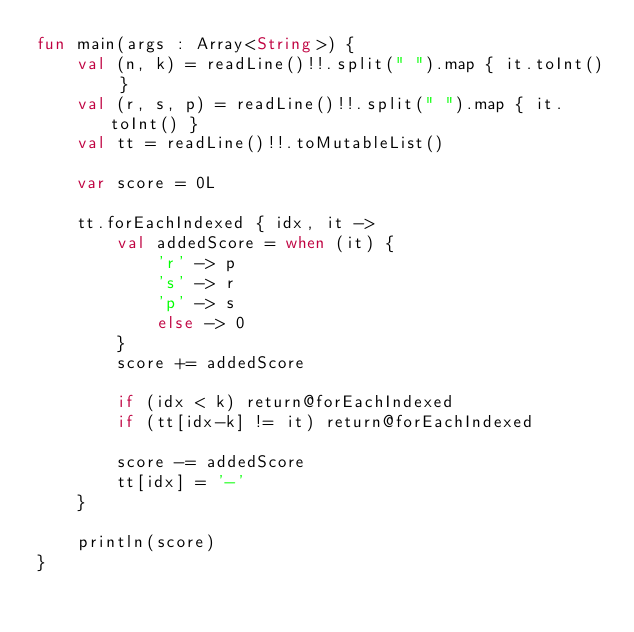<code> <loc_0><loc_0><loc_500><loc_500><_Kotlin_>fun main(args : Array<String>) {
    val (n, k) = readLine()!!.split(" ").map { it.toInt() }
    val (r, s, p) = readLine()!!.split(" ").map { it.toInt() }
    val tt = readLine()!!.toMutableList()

    var score = 0L

    tt.forEachIndexed { idx, it ->
        val addedScore = when (it) {
            'r' -> p
            's' -> r
            'p' -> s
            else -> 0
        }
        score += addedScore

        if (idx < k) return@forEachIndexed
        if (tt[idx-k] != it) return@forEachIndexed

        score -= addedScore
        tt[idx] = '-'
    }

    println(score)
}
</code> 